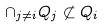<formula> <loc_0><loc_0><loc_500><loc_500>\cap _ { j \neq i } Q _ { j } \not \subset Q _ { i }</formula> 